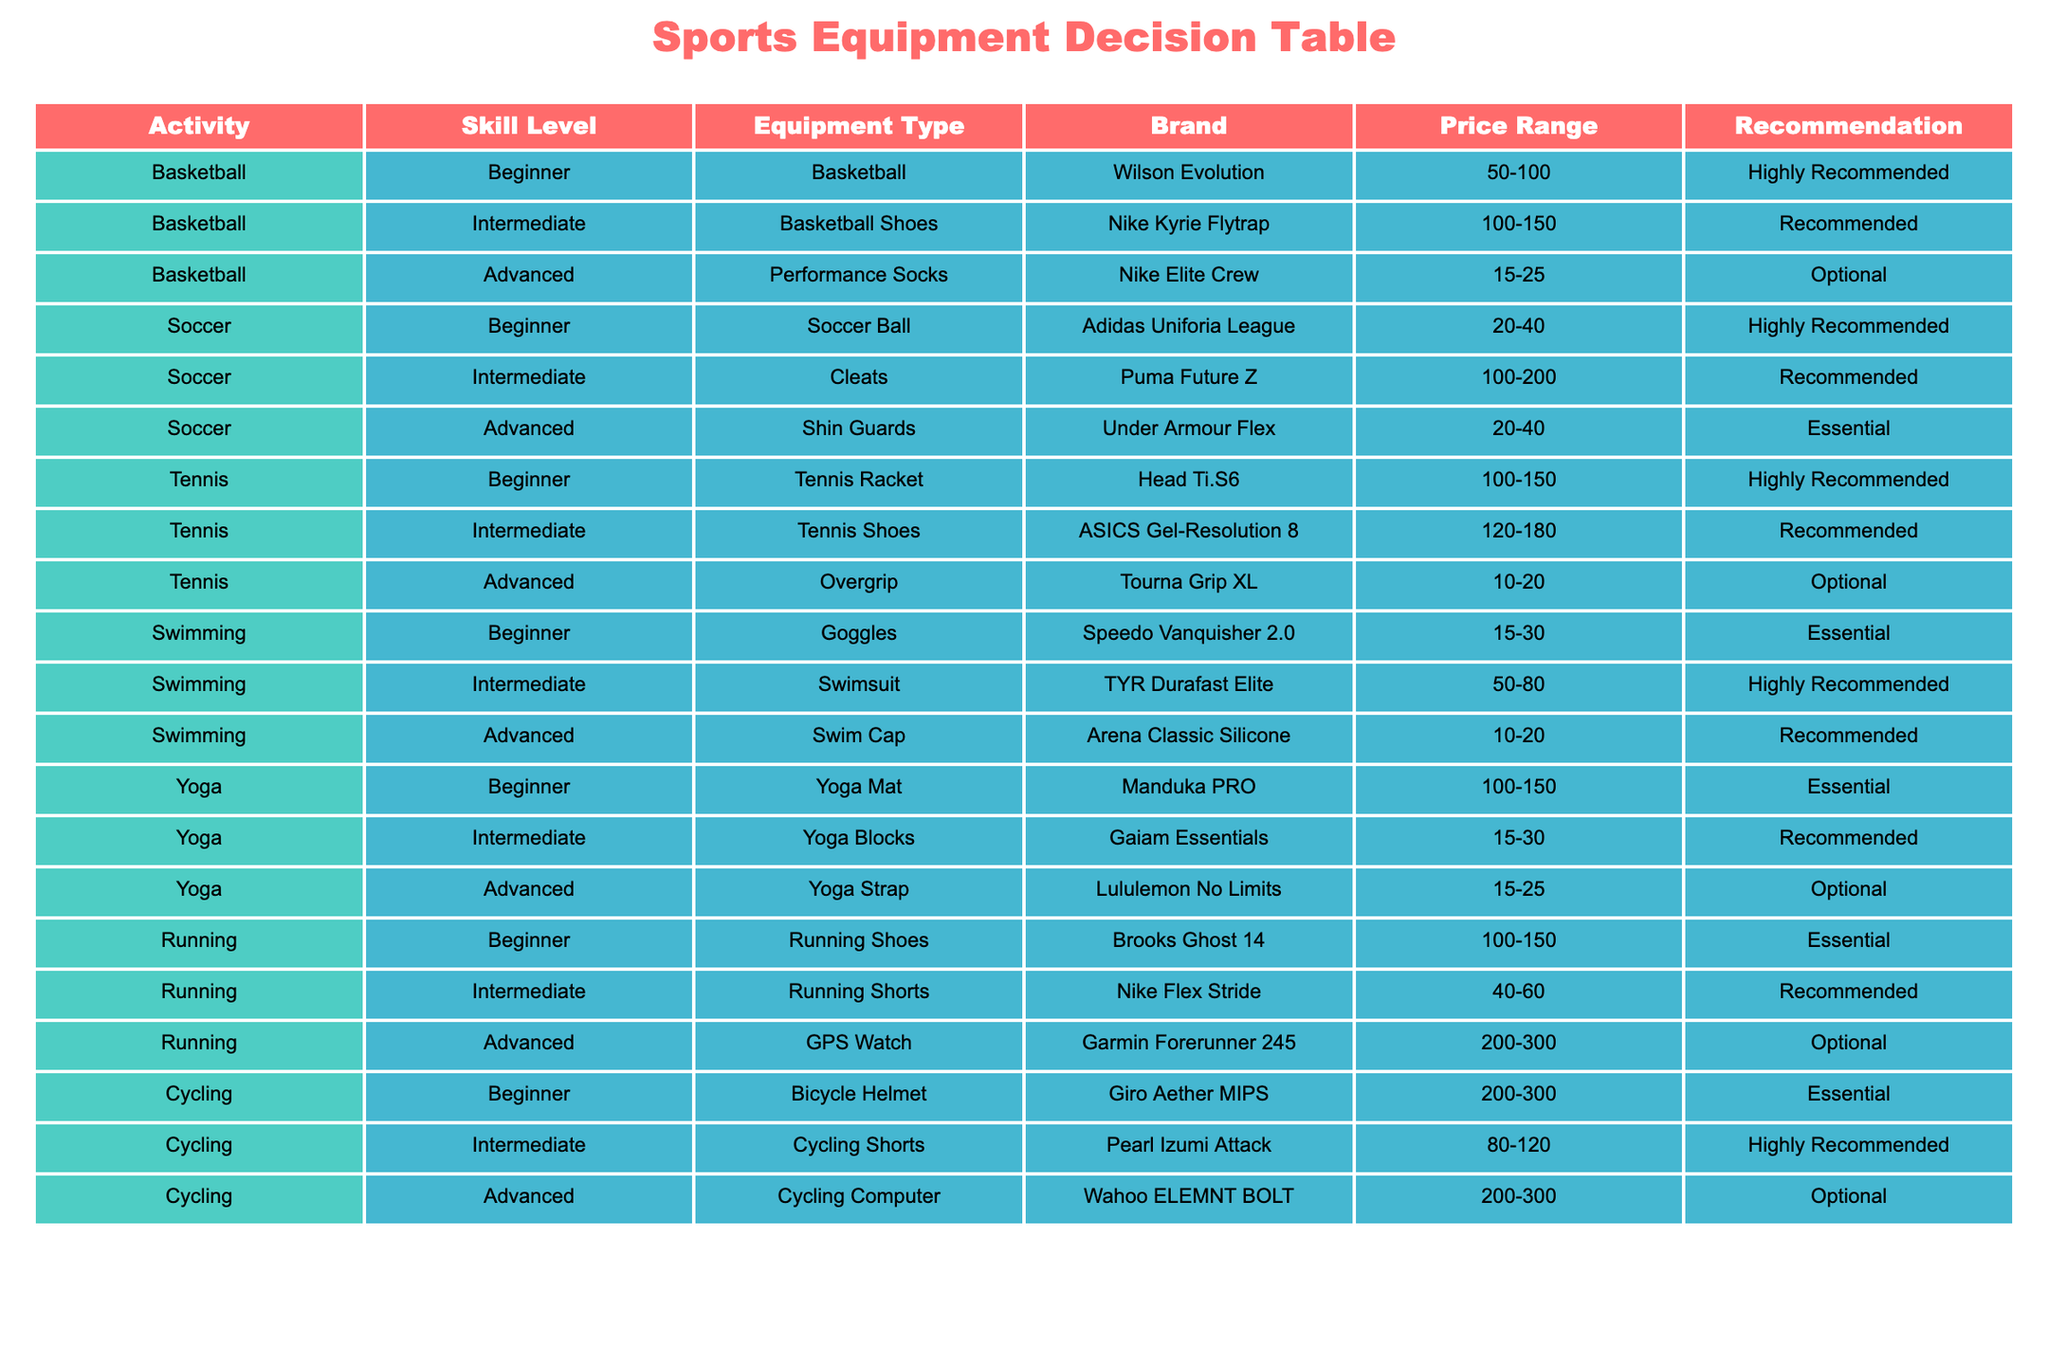What equipment is recommended for a beginner in soccer? According to the table, the recommended equipment for a beginner in soccer is the Adidas Uniforia League soccer ball, which is categorized as "Highly Recommended."
Answer: Adidas Uniforia League soccer ball Which activity has the most recommended equipment types? To find the activity with the most recommended equipment types, we can count the number of "Recommended" classifications for each activity: Basketball (2), Soccer (2), Tennis (2), Swimming (2), Yoga (2), Running (2), Cycling (2). All activities have the same count of recommended types, equaling 2 each. Therefore, there is no distinct activity; they are equally represented.
Answer: All activities are equally represented Do advanced swimmers need a swimsuit? Referring to the table, advanced swimmers are recommended a swim cap (not a swimsuit), which is noted as "Recommended." Therefore, they do not need a swimsuit as it is categorized under intermediate skill level.
Answer: No What is the price range for equipment recommended for intermediate tennis players? The price range for equipment recommended for intermediate tennis players, specifically the ASICS Gel-Resolution 8 tennis shoes, is 120-180. This can be directly pulled from the relevant row in the table.
Answer: 120-180 How many essential pieces of equipment are listed in the table? From the table, we can filter for essential equipment recommendations and count them: Soccer shin guards, swimming goggles, yoga mats, and cycling helmets. There are four items in total classified as "Essential."
Answer: Four items 